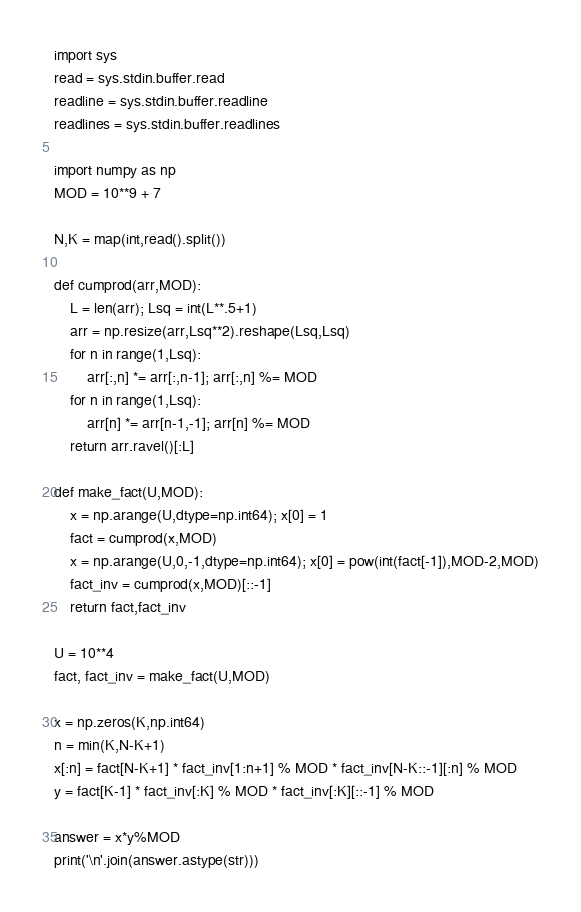Convert code to text. <code><loc_0><loc_0><loc_500><loc_500><_Python_>import sys
read = sys.stdin.buffer.read
readline = sys.stdin.buffer.readline
readlines = sys.stdin.buffer.readlines

import numpy as np
MOD = 10**9 + 7

N,K = map(int,read().split())

def cumprod(arr,MOD):
    L = len(arr); Lsq = int(L**.5+1)
    arr = np.resize(arr,Lsq**2).reshape(Lsq,Lsq)
    for n in range(1,Lsq):
        arr[:,n] *= arr[:,n-1]; arr[:,n] %= MOD
    for n in range(1,Lsq):
        arr[n] *= arr[n-1,-1]; arr[n] %= MOD
    return arr.ravel()[:L]

def make_fact(U,MOD):
    x = np.arange(U,dtype=np.int64); x[0] = 1
    fact = cumprod(x,MOD)
    x = np.arange(U,0,-1,dtype=np.int64); x[0] = pow(int(fact[-1]),MOD-2,MOD)
    fact_inv = cumprod(x,MOD)[::-1]
    return fact,fact_inv

U = 10**4
fact, fact_inv = make_fact(U,MOD)

x = np.zeros(K,np.int64)
n = min(K,N-K+1)
x[:n] = fact[N-K+1] * fact_inv[1:n+1] % MOD * fact_inv[N-K::-1][:n] % MOD
y = fact[K-1] * fact_inv[:K] % MOD * fact_inv[:K][::-1] % MOD

answer = x*y%MOD
print('\n'.join(answer.astype(str)))</code> 